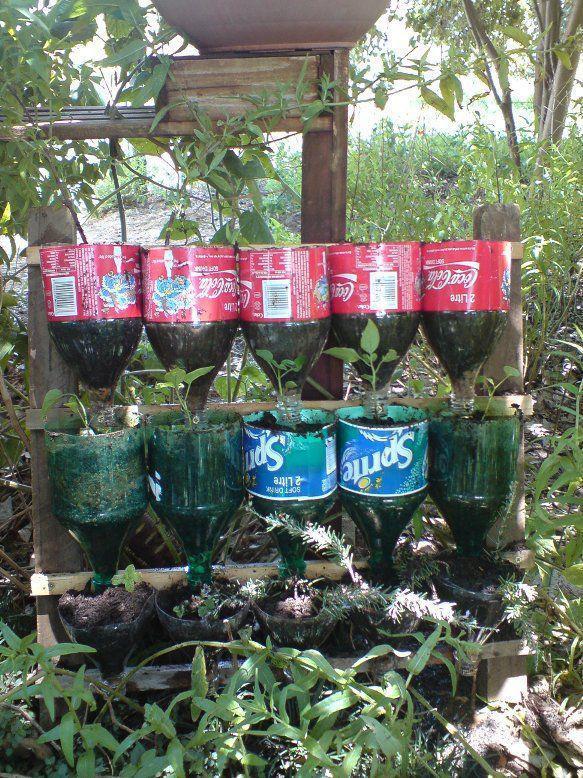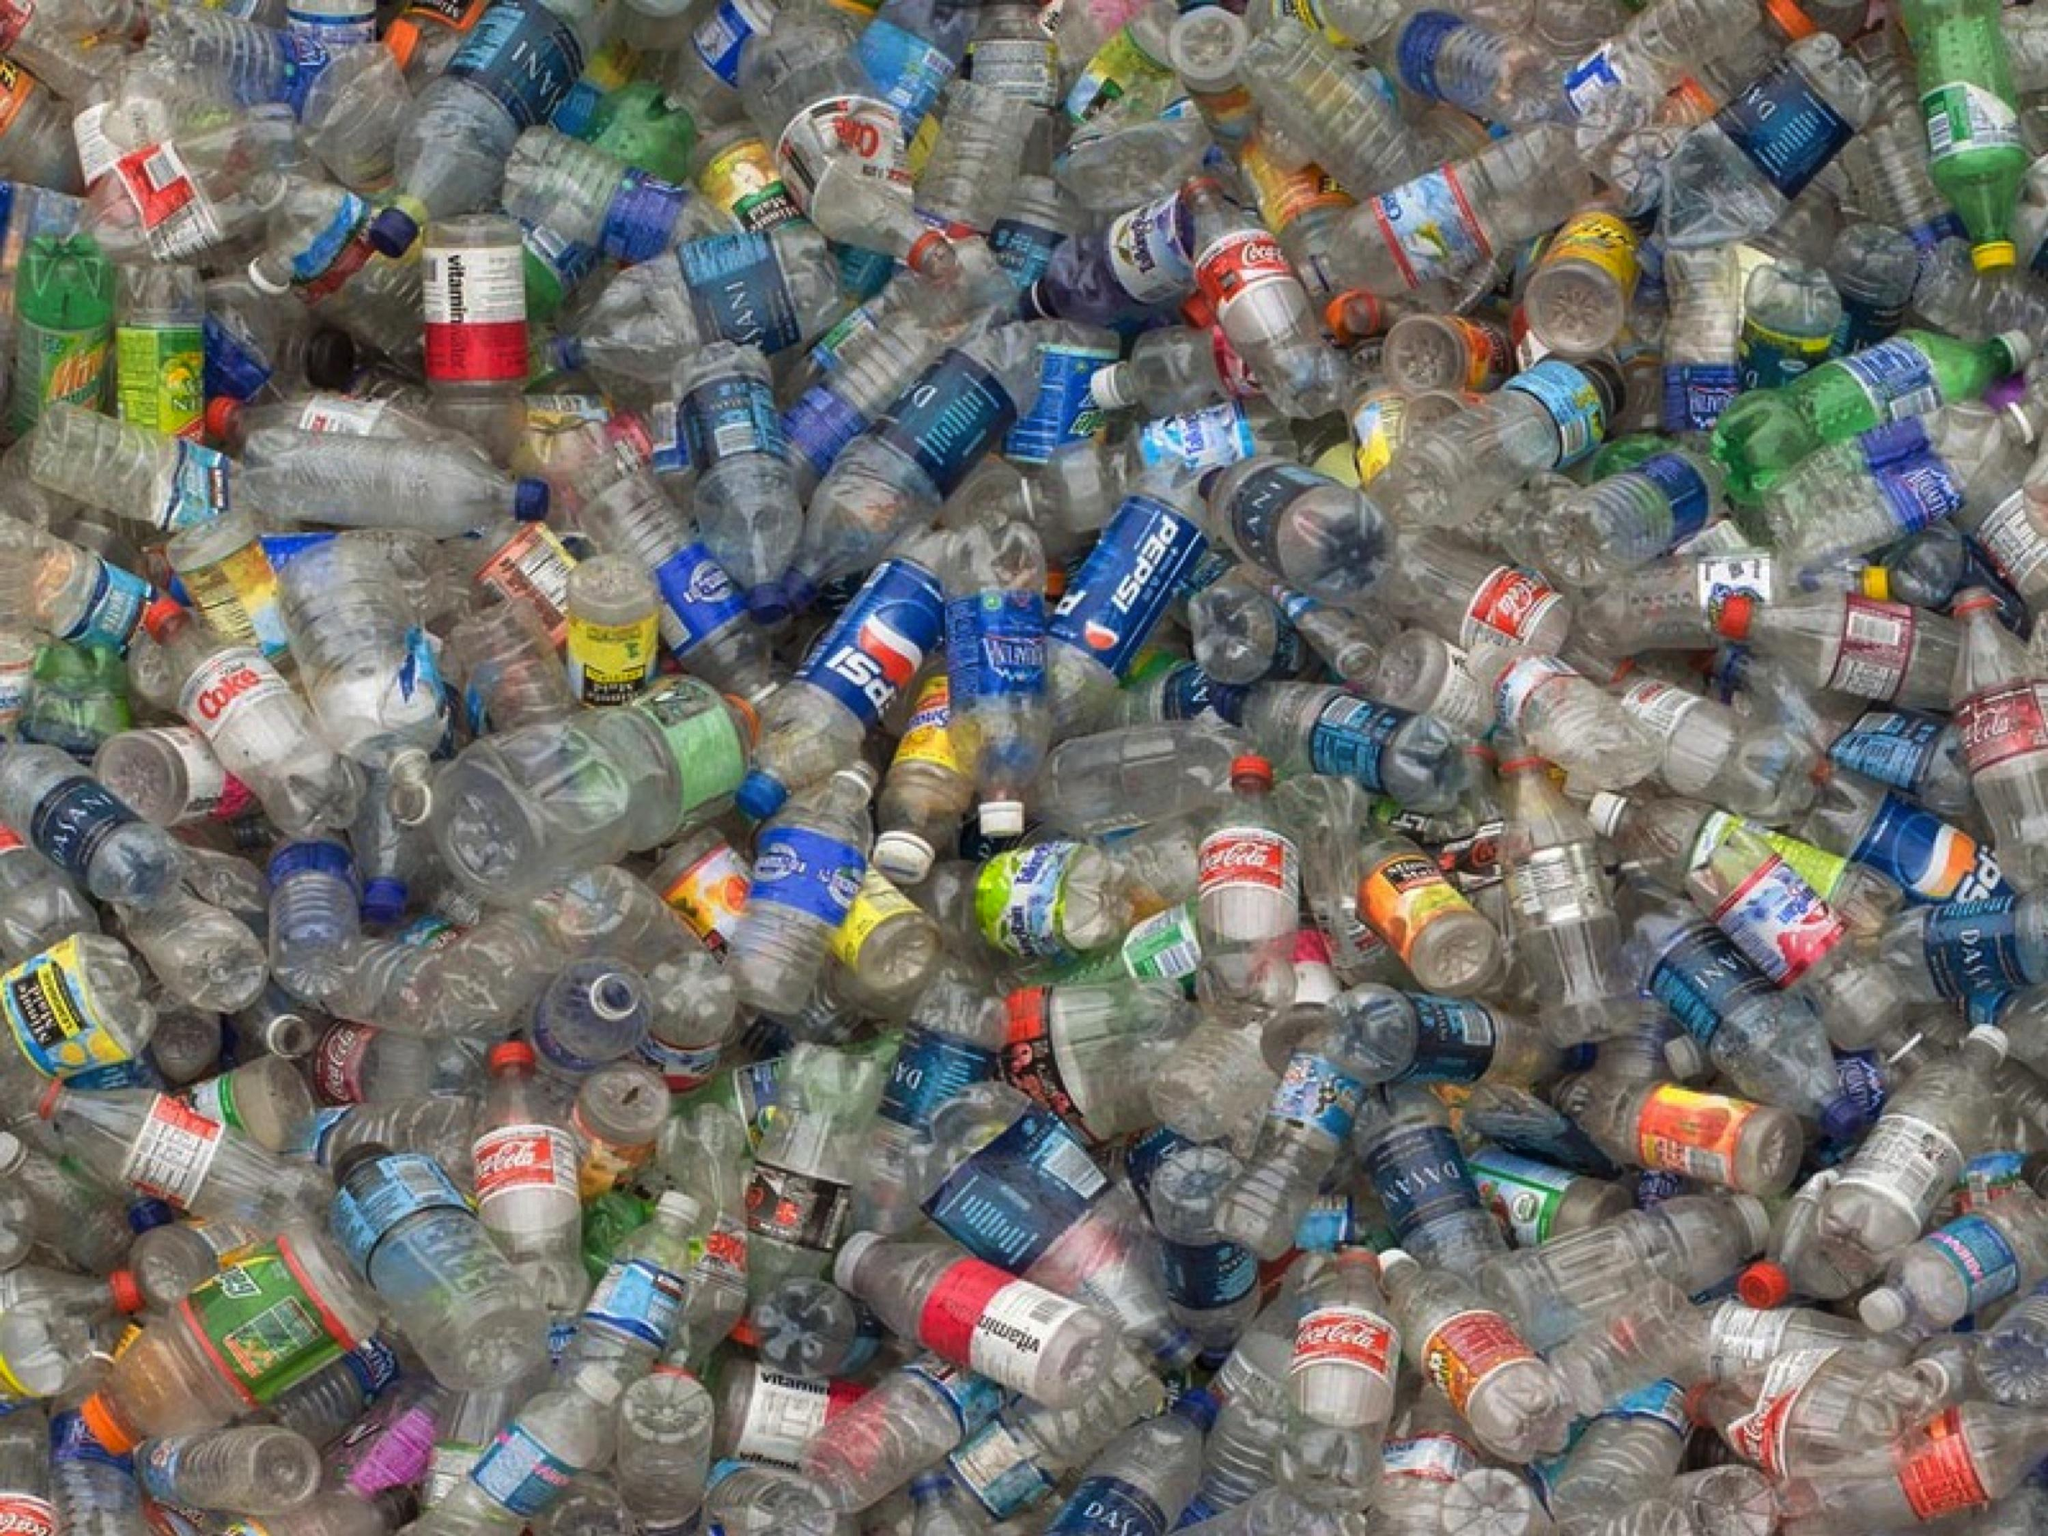The first image is the image on the left, the second image is the image on the right. Given the left and right images, does the statement "One of the images contains two or fewer bottles." hold true? Answer yes or no. No. The first image is the image on the left, the second image is the image on the right. Considering the images on both sides, is "Some bottles are cut open." valid? Answer yes or no. Yes. 